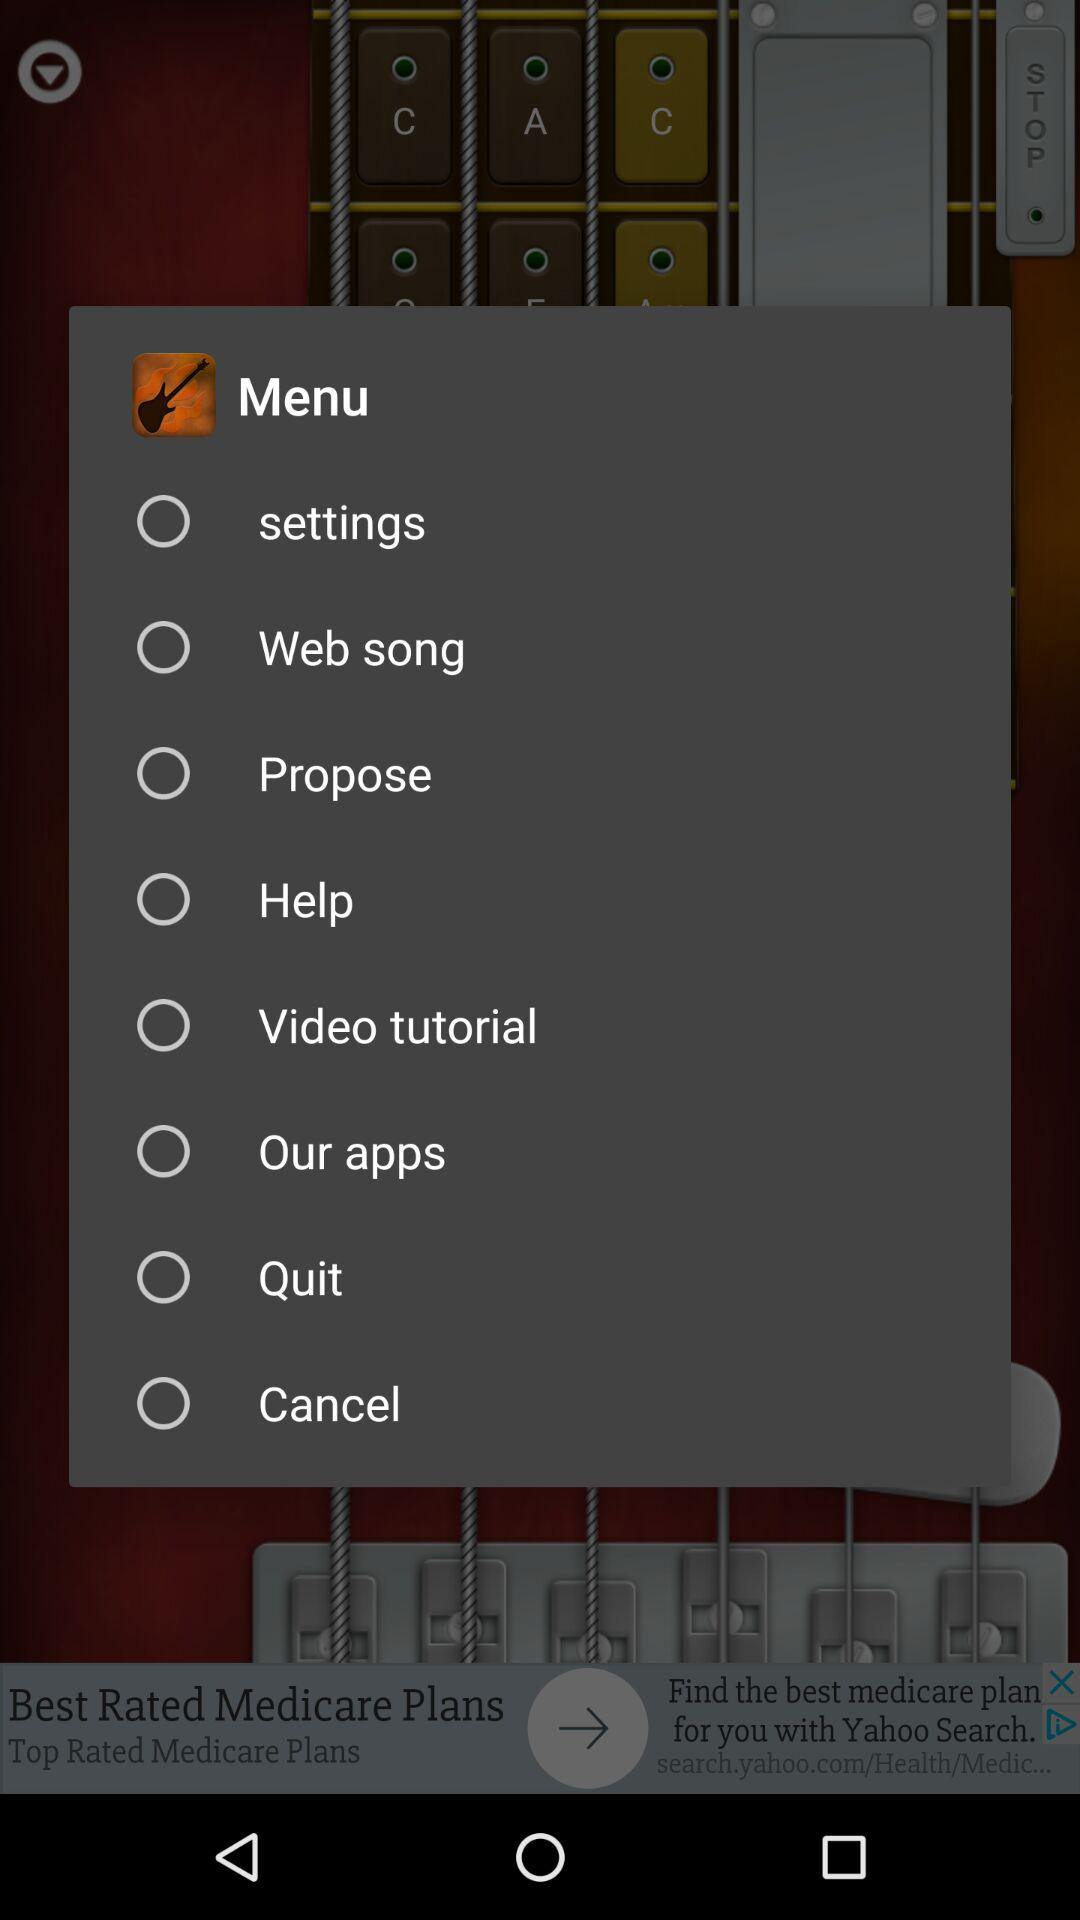What are the different menu options? The different menu options are : "settings", "Web song", "Propose", "Help", "Video tutorial", "Our apps", "Quit", and "Cancel". 